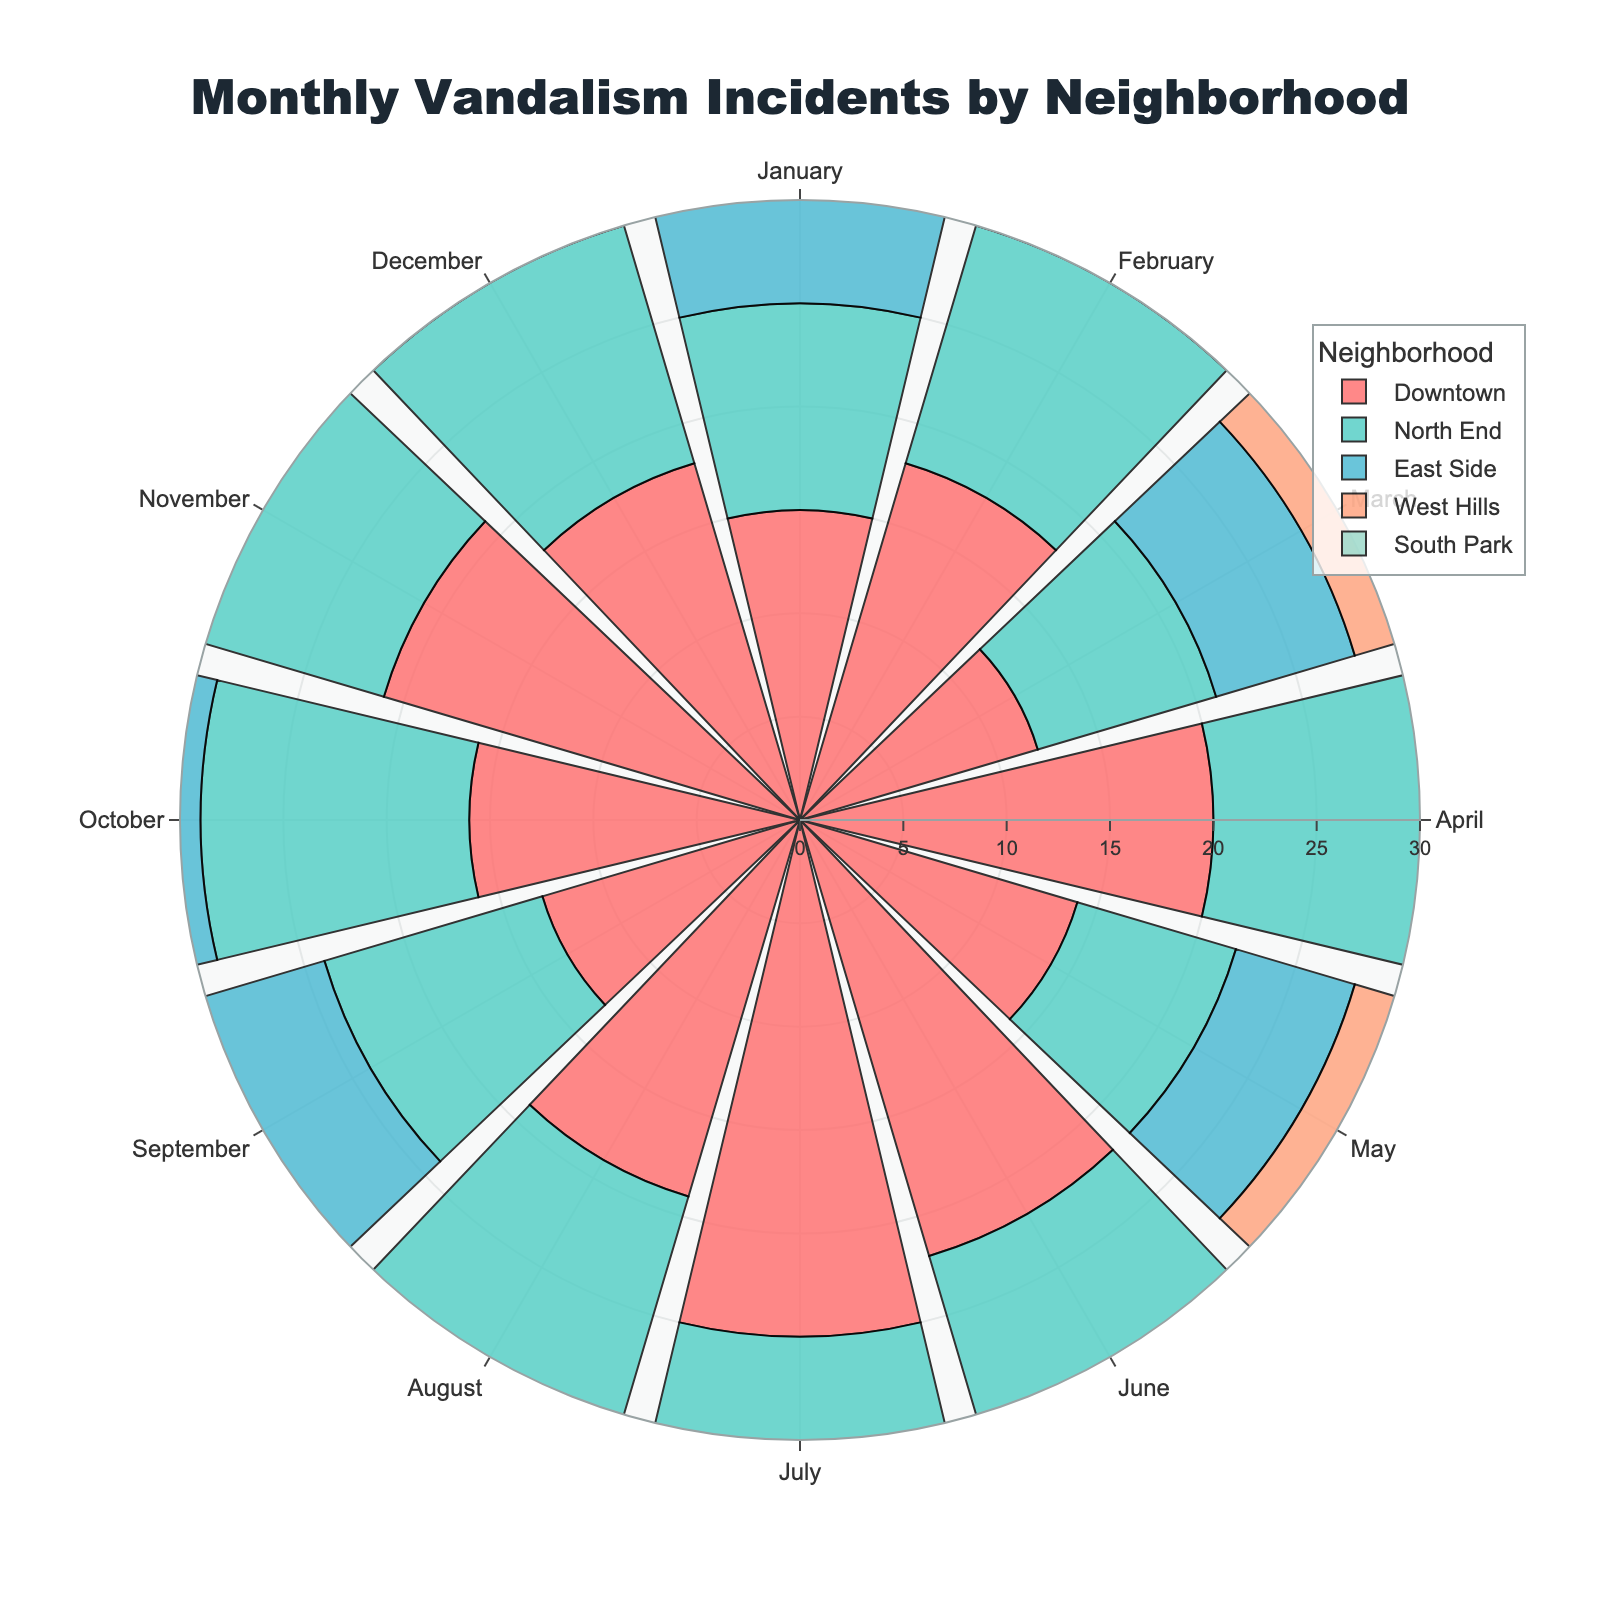Which neighborhood has the highest number of vandalism incidents in July? Observing the radial bar lengths for July in the figure, the neighborhood with the longest bar has the highest number of incidents. The bar for Downtown is the longest.
Answer: Downtown What is the total number of vandalism incidents in Downtown during the winter months (December, January, February)? Sum the incidents in December, January, and February for Downtown: 18 (December) + 15 (January) + 18 (February) = 51
Answer: 51 Which neighborhood experienced the lowest number of vandalism incidents overall? Looking for the neighborhood with the generally shorter bars throughout the chart, South Park has the smallest total number of incidents.
Answer: South Park How does the number of incidents in North End in June compare to that in West Hills in June? Compare the length of the bars for North End and West Hills in June. North End has 14 incidents, while West Hills has 19, making West Hills higher.
Answer: West Hills Which month and neighborhood combination had the peak number of incidents? Identify the longest bar in the entire chart. The longest bar is for Downtown in July with 25 incidents.
Answer: Downtown in July What is the average number of incidents per month in the East Side? Sum the 12 monthly incident counts for East Side: 9 + 11 + 7 + 12 + 6 + 13 + 16 + 10 + 8 + 9 + 12 + 11 = 124, and then divide by 12, so the average is 124/12 ≈ 10.33
Answer: 10.33 How do the incidents in South Park in May compare to Downtown in May? Compare the bars for South Park and Downtown in May. South Park has 5 incidents, while Downtown has 14 incidents. Downtown has more.
Answer: Downtown Which month generally sees a peak in vandalism incidents across most neighborhoods? Check for the month where multiple neighborhoods have notably higher incidents. July has higher bars across several neighborhoods, indicating a peak.
Answer: July Is there a significant difference between the number of incidents between April and May in West Hills? Compare the bar lengths for West Hills in April and May. April (18) and May (9) have a visible difference, with April nearly double May.
Answer: Yes Which neighborhood has the most consistency in the number of incidents throughout the year? Look for the neighborhood with bars of similar length across months. South Park shows the most consistency, with incidents staying relatively low and constant.
Answer: South Park 